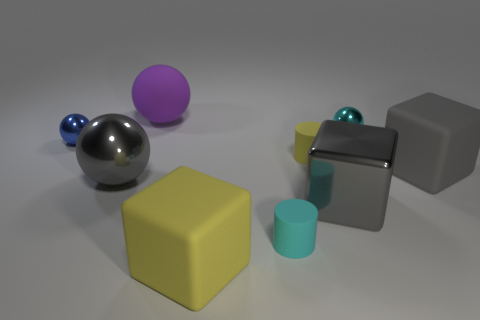There is another cube that is the same color as the metal cube; what material is it?
Provide a short and direct response. Rubber. There is a shiny cube; is its size the same as the matte thing behind the blue sphere?
Your response must be concise. Yes. What number of other objects are the same material as the purple object?
Keep it short and to the point. 4. What number of things are tiny cylinders that are behind the small cyan cylinder or metallic things that are to the right of the large yellow cube?
Provide a succinct answer. 3. What material is the purple thing that is the same shape as the blue metallic thing?
Keep it short and to the point. Rubber. Are there any big gray blocks?
Offer a very short reply. Yes. There is a metallic thing that is on the right side of the tiny yellow object and in front of the cyan metallic sphere; what size is it?
Offer a terse response. Large. What is the shape of the gray matte object?
Make the answer very short. Cube. Are there any tiny cyan matte things that are left of the ball in front of the gray rubber block?
Provide a succinct answer. No. What is the material of the purple sphere that is the same size as the yellow block?
Make the answer very short. Rubber. 